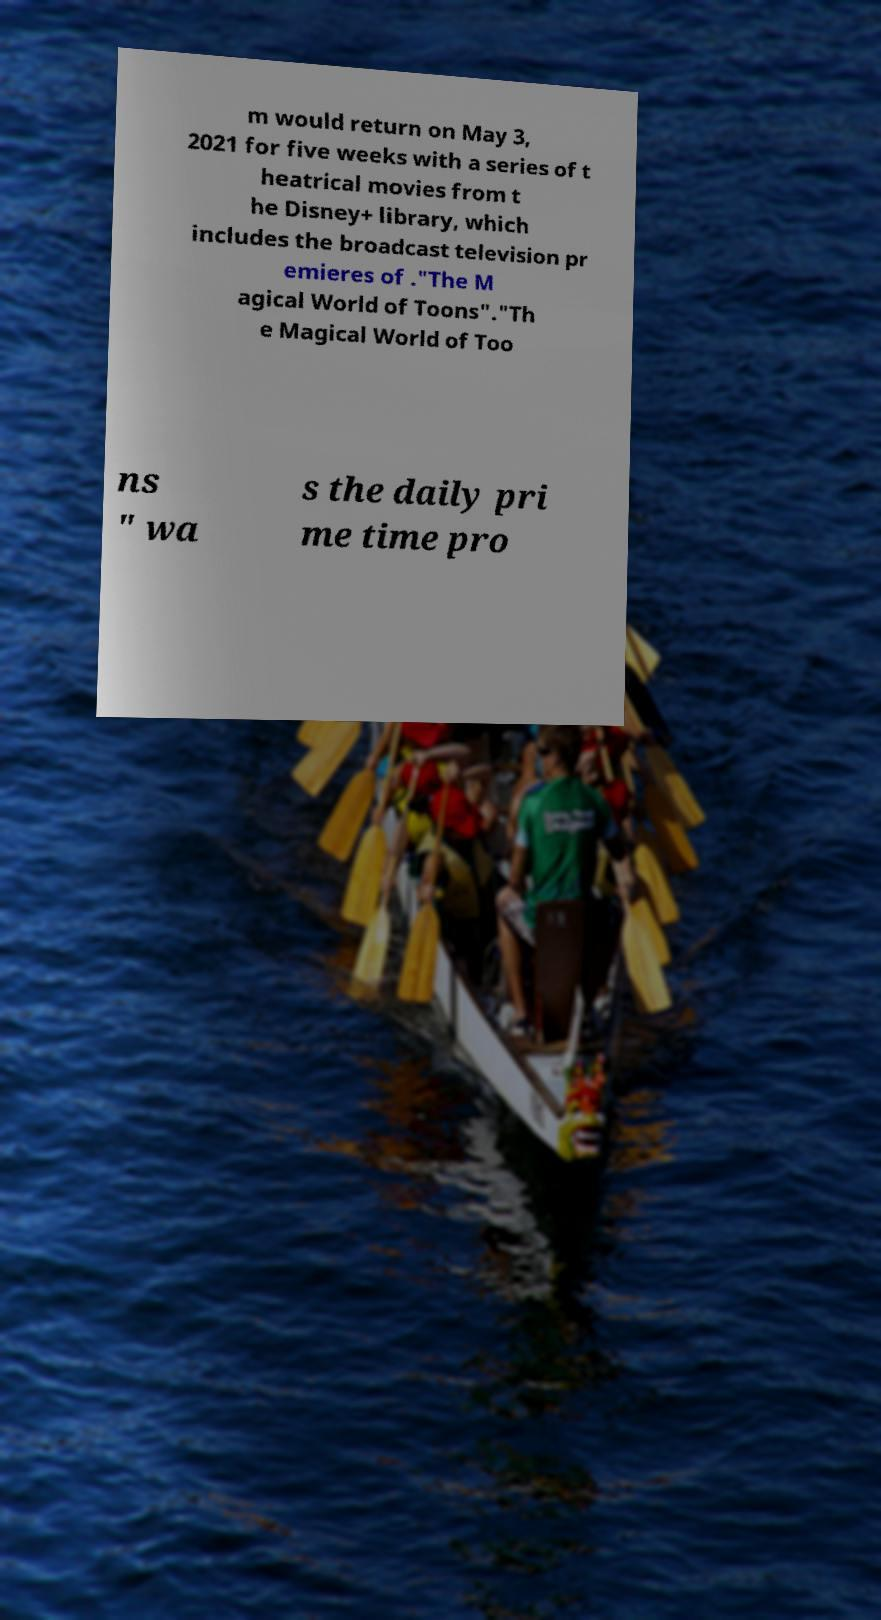Could you extract and type out the text from this image? m would return on May 3, 2021 for five weeks with a series of t heatrical movies from t he Disney+ library, which includes the broadcast television pr emieres of ."The M agical World of Toons"."Th e Magical World of Too ns " wa s the daily pri me time pro 